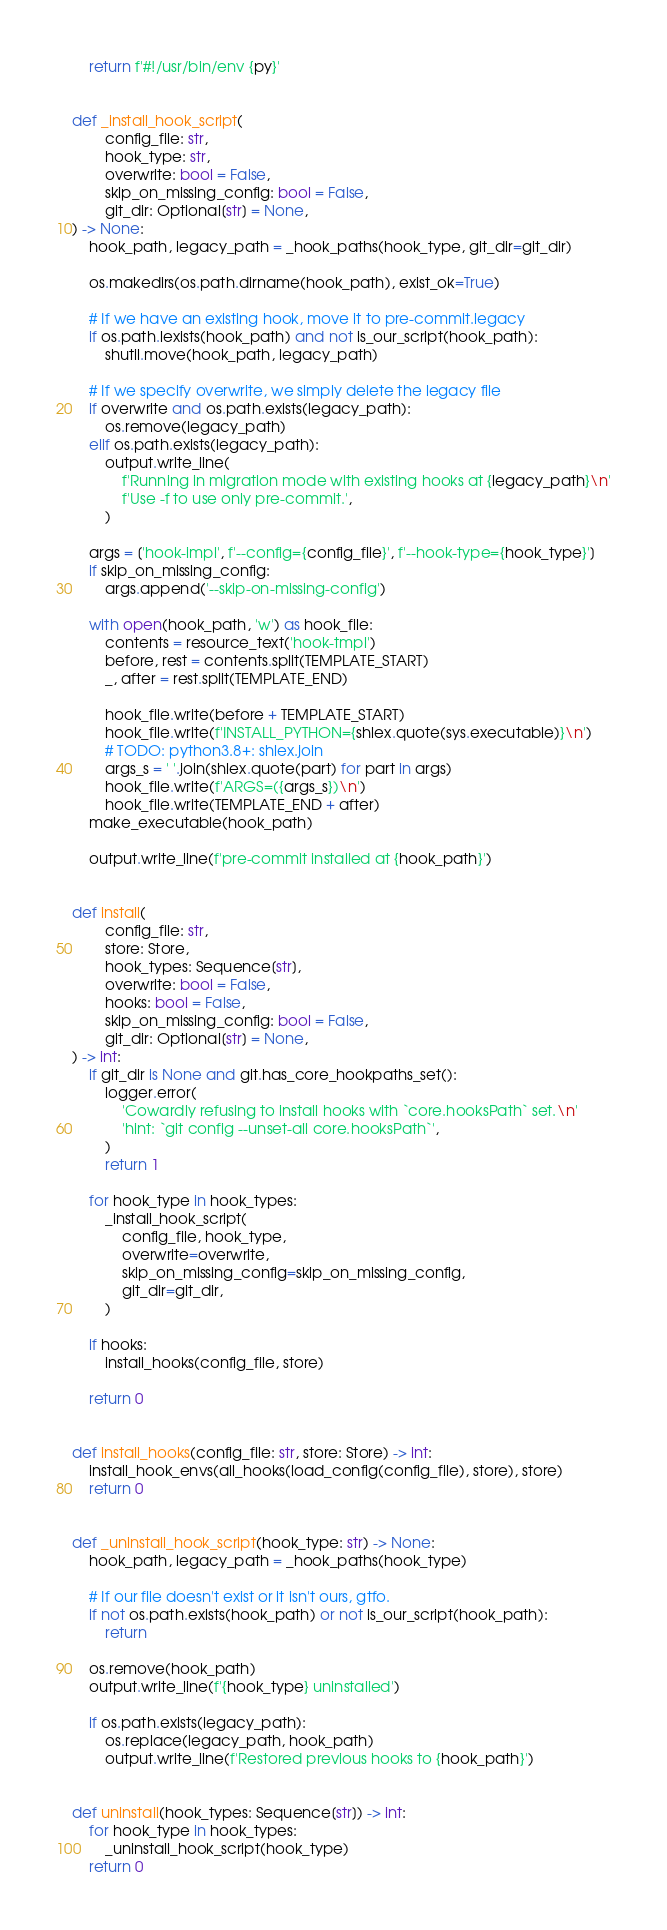<code> <loc_0><loc_0><loc_500><loc_500><_Python_>    return f'#!/usr/bin/env {py}'


def _install_hook_script(
        config_file: str,
        hook_type: str,
        overwrite: bool = False,
        skip_on_missing_config: bool = False,
        git_dir: Optional[str] = None,
) -> None:
    hook_path, legacy_path = _hook_paths(hook_type, git_dir=git_dir)

    os.makedirs(os.path.dirname(hook_path), exist_ok=True)

    # If we have an existing hook, move it to pre-commit.legacy
    if os.path.lexists(hook_path) and not is_our_script(hook_path):
        shutil.move(hook_path, legacy_path)

    # If we specify overwrite, we simply delete the legacy file
    if overwrite and os.path.exists(legacy_path):
        os.remove(legacy_path)
    elif os.path.exists(legacy_path):
        output.write_line(
            f'Running in migration mode with existing hooks at {legacy_path}\n'
            f'Use -f to use only pre-commit.',
        )

    args = ['hook-impl', f'--config={config_file}', f'--hook-type={hook_type}']
    if skip_on_missing_config:
        args.append('--skip-on-missing-config')

    with open(hook_path, 'w') as hook_file:
        contents = resource_text('hook-tmpl')
        before, rest = contents.split(TEMPLATE_START)
        _, after = rest.split(TEMPLATE_END)

        hook_file.write(before + TEMPLATE_START)
        hook_file.write(f'INSTALL_PYTHON={shlex.quote(sys.executable)}\n')
        # TODO: python3.8+: shlex.join
        args_s = ' '.join(shlex.quote(part) for part in args)
        hook_file.write(f'ARGS=({args_s})\n')
        hook_file.write(TEMPLATE_END + after)
    make_executable(hook_path)

    output.write_line(f'pre-commit installed at {hook_path}')


def install(
        config_file: str,
        store: Store,
        hook_types: Sequence[str],
        overwrite: bool = False,
        hooks: bool = False,
        skip_on_missing_config: bool = False,
        git_dir: Optional[str] = None,
) -> int:
    if git_dir is None and git.has_core_hookpaths_set():
        logger.error(
            'Cowardly refusing to install hooks with `core.hooksPath` set.\n'
            'hint: `git config --unset-all core.hooksPath`',
        )
        return 1

    for hook_type in hook_types:
        _install_hook_script(
            config_file, hook_type,
            overwrite=overwrite,
            skip_on_missing_config=skip_on_missing_config,
            git_dir=git_dir,
        )

    if hooks:
        install_hooks(config_file, store)

    return 0


def install_hooks(config_file: str, store: Store) -> int:
    install_hook_envs(all_hooks(load_config(config_file), store), store)
    return 0


def _uninstall_hook_script(hook_type: str) -> None:
    hook_path, legacy_path = _hook_paths(hook_type)

    # If our file doesn't exist or it isn't ours, gtfo.
    if not os.path.exists(hook_path) or not is_our_script(hook_path):
        return

    os.remove(hook_path)
    output.write_line(f'{hook_type} uninstalled')

    if os.path.exists(legacy_path):
        os.replace(legacy_path, hook_path)
        output.write_line(f'Restored previous hooks to {hook_path}')


def uninstall(hook_types: Sequence[str]) -> int:
    for hook_type in hook_types:
        _uninstall_hook_script(hook_type)
    return 0
</code> 